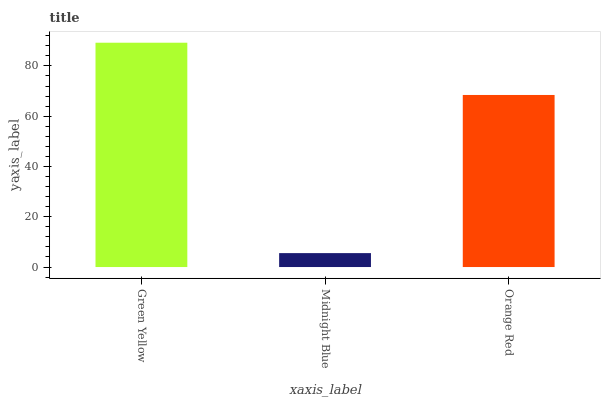Is Midnight Blue the minimum?
Answer yes or no. Yes. Is Green Yellow the maximum?
Answer yes or no. Yes. Is Orange Red the minimum?
Answer yes or no. No. Is Orange Red the maximum?
Answer yes or no. No. Is Orange Red greater than Midnight Blue?
Answer yes or no. Yes. Is Midnight Blue less than Orange Red?
Answer yes or no. Yes. Is Midnight Blue greater than Orange Red?
Answer yes or no. No. Is Orange Red less than Midnight Blue?
Answer yes or no. No. Is Orange Red the high median?
Answer yes or no. Yes. Is Orange Red the low median?
Answer yes or no. Yes. Is Midnight Blue the high median?
Answer yes or no. No. Is Midnight Blue the low median?
Answer yes or no. No. 